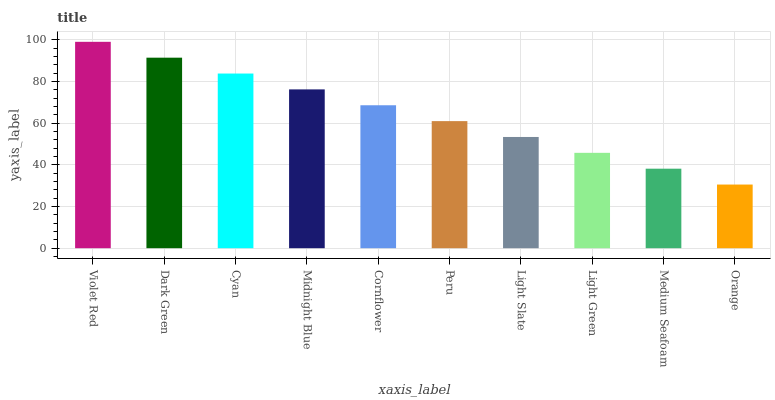Is Orange the minimum?
Answer yes or no. Yes. Is Violet Red the maximum?
Answer yes or no. Yes. Is Dark Green the minimum?
Answer yes or no. No. Is Dark Green the maximum?
Answer yes or no. No. Is Violet Red greater than Dark Green?
Answer yes or no. Yes. Is Dark Green less than Violet Red?
Answer yes or no. Yes. Is Dark Green greater than Violet Red?
Answer yes or no. No. Is Violet Red less than Dark Green?
Answer yes or no. No. Is Cornflower the high median?
Answer yes or no. Yes. Is Peru the low median?
Answer yes or no. Yes. Is Light Green the high median?
Answer yes or no. No. Is Orange the low median?
Answer yes or no. No. 